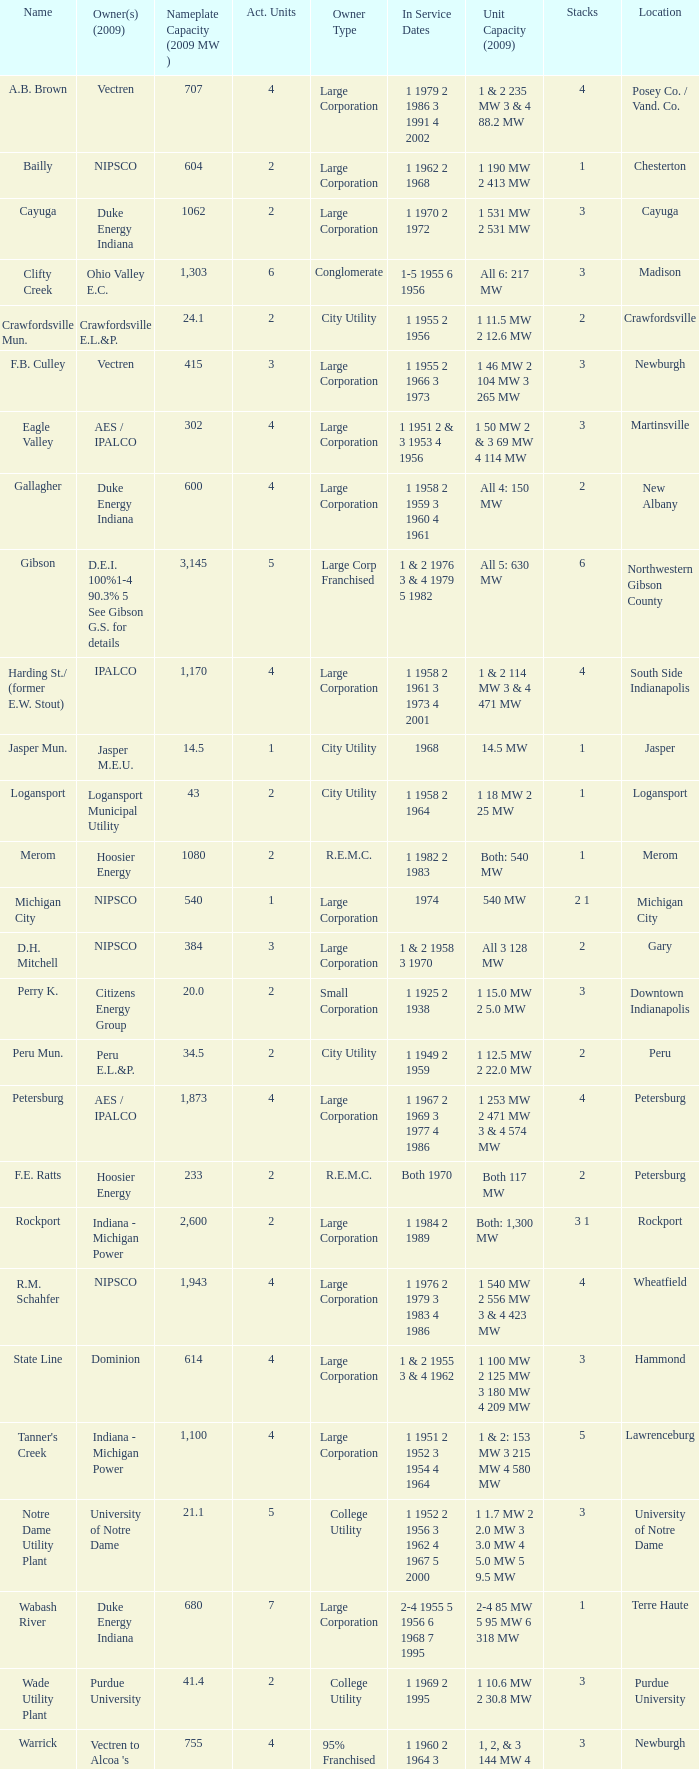Name the number for service dates for hoosier energy for petersburg 1.0. 